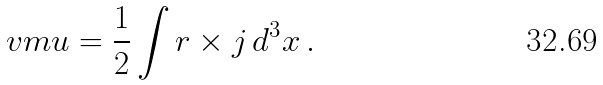Convert formula to latex. <formula><loc_0><loc_0><loc_500><loc_500>\ v m u = \frac { 1 } { 2 } \int { r } \times { j } \, { d } ^ { 3 } x \, .</formula> 